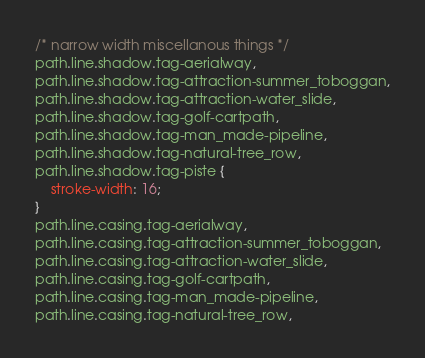Convert code to text. <code><loc_0><loc_0><loc_500><loc_500><_CSS_>
/* narrow width miscellanous things */
path.line.shadow.tag-aerialway,
path.line.shadow.tag-attraction-summer_toboggan,
path.line.shadow.tag-attraction-water_slide,
path.line.shadow.tag-golf-cartpath,
path.line.shadow.tag-man_made-pipeline,
path.line.shadow.tag-natural-tree_row,
path.line.shadow.tag-piste {
    stroke-width: 16;
}
path.line.casing.tag-aerialway,
path.line.casing.tag-attraction-summer_toboggan,
path.line.casing.tag-attraction-water_slide,
path.line.casing.tag-golf-cartpath,
path.line.casing.tag-man_made-pipeline,
path.line.casing.tag-natural-tree_row,</code> 